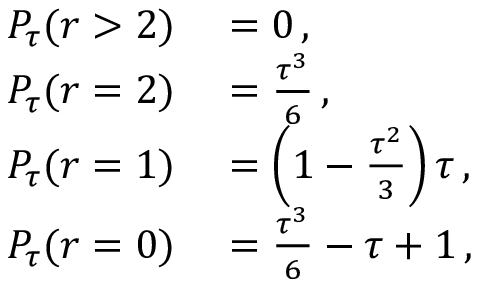Convert formula to latex. <formula><loc_0><loc_0><loc_500><loc_500>\begin{array} { r l } { P _ { \tau } ( r > 2 ) } & = 0 \, , } \\ { P _ { \tau } ( r = 2 ) } & = \frac { \tau ^ { 3 } } { 6 } \, , } \\ { P _ { \tau } ( r = 1 ) } & = \left ( 1 - \frac { \tau ^ { 2 } } { 3 } \right ) \tau \, , } \\ { P _ { \tau } ( r = 0 ) } & = \frac { \tau ^ { 3 } } { 6 } - \tau + 1 \, , } \end{array}</formula> 